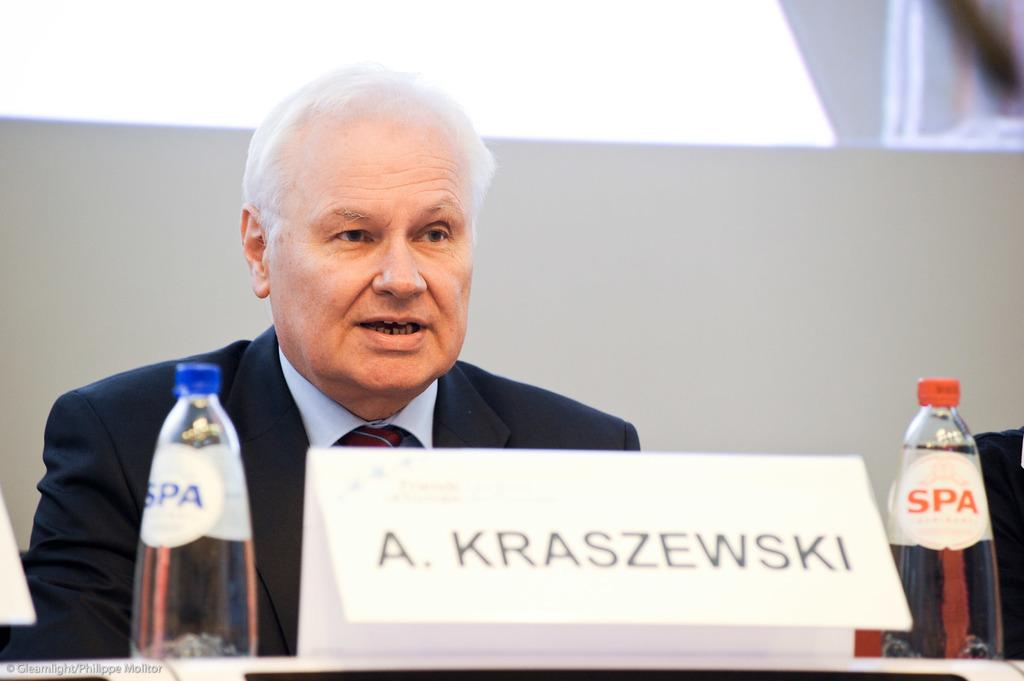What is the person in the image doing? The person is sitting and talking to someone in the image. What is present in the image besides the person? There is a table, two bottles, and a name board in the board in the image. What might the person be using to communicate with the other person? The person might be using the table to hold items or support their conversation. What type of berry is being used as a prop in the image? There is no berry present in the image. How many legs does the person in the image have? The person in the image has two legs, as is typical for humans. 